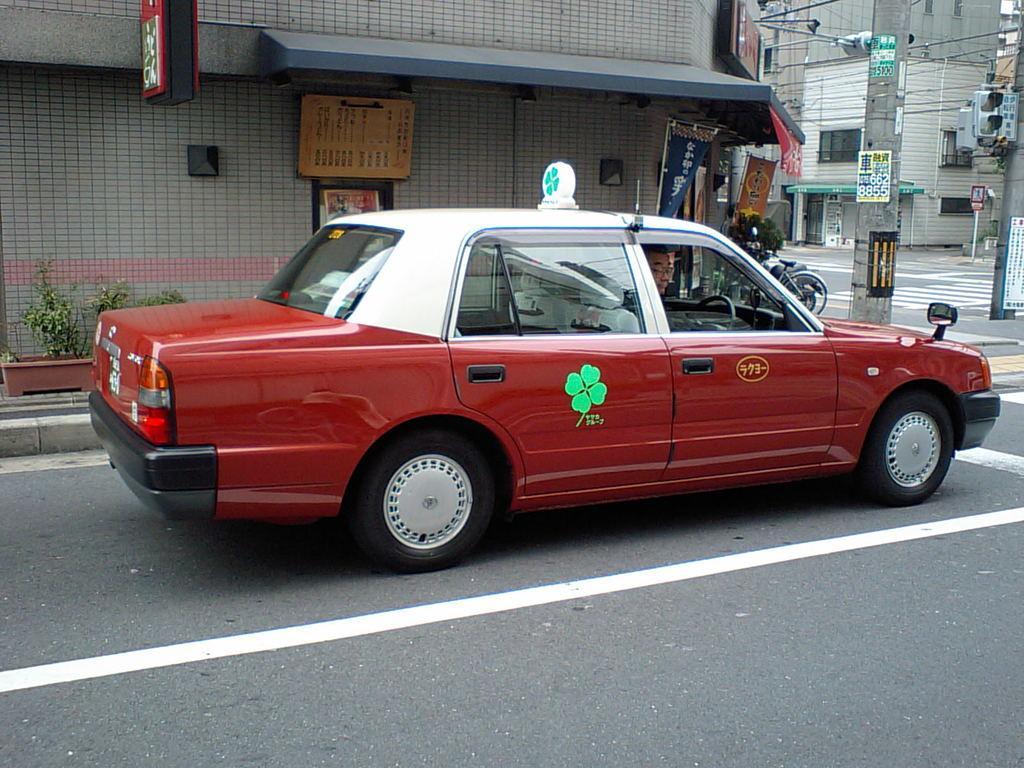How would you summarize this image in a sentence or two? This is the picture of a road. In this image there is a person sitting inside the car, there is a car on the road. At the back there are buildings and poles. There are hoardings on the buildings and broads, wires on the pole. There are plants and bicycles on the footpath. At the bottom there is a road. 